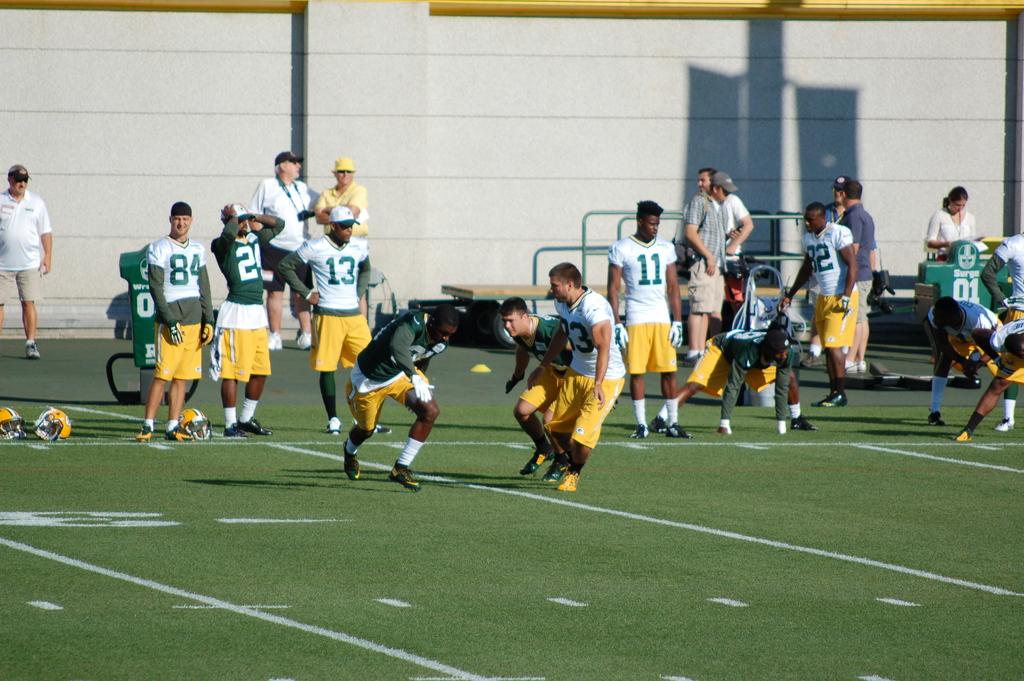Jersey number on the left (white)?
Your response must be concise. 84. What number is on the player in whites jersey on the right?
Provide a succinct answer. 11. 